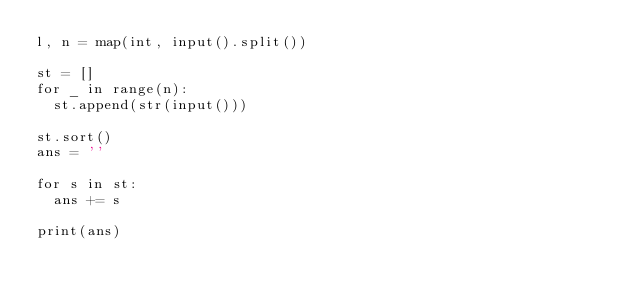<code> <loc_0><loc_0><loc_500><loc_500><_Python_>l, n = map(int, input().split())

st = []
for _ in range(n):
  st.append(str(input()))

st.sort()
ans = ''

for s in st:
  ans += s
  
print(ans)
</code> 